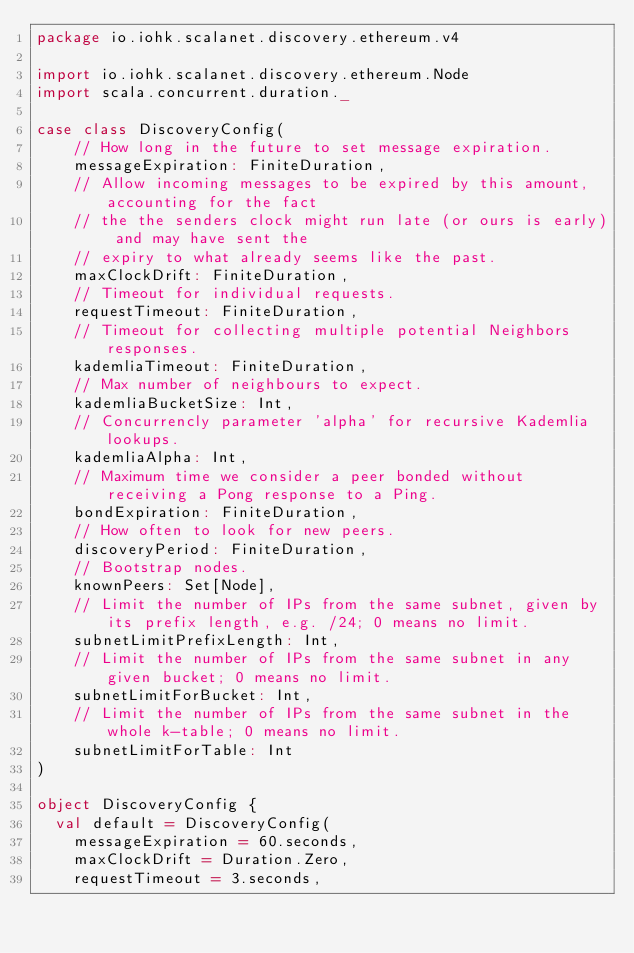Convert code to text. <code><loc_0><loc_0><loc_500><loc_500><_Scala_>package io.iohk.scalanet.discovery.ethereum.v4

import io.iohk.scalanet.discovery.ethereum.Node
import scala.concurrent.duration._

case class DiscoveryConfig(
    // How long in the future to set message expiration.
    messageExpiration: FiniteDuration,
    // Allow incoming messages to be expired by this amount, accounting for the fact
    // the the senders clock might run late (or ours is early) and may have sent the
    // expiry to what already seems like the past.
    maxClockDrift: FiniteDuration,
    // Timeout for individual requests.
    requestTimeout: FiniteDuration,
    // Timeout for collecting multiple potential Neighbors responses.
    kademliaTimeout: FiniteDuration,
    // Max number of neighbours to expect.
    kademliaBucketSize: Int,
    // Concurrencly parameter 'alpha' for recursive Kademlia lookups.
    kademliaAlpha: Int,
    // Maximum time we consider a peer bonded without receiving a Pong response to a Ping.
    bondExpiration: FiniteDuration,
    // How often to look for new peers.
    discoveryPeriod: FiniteDuration,
    // Bootstrap nodes.
    knownPeers: Set[Node],
    // Limit the number of IPs from the same subnet, given by its prefix length, e.g. /24; 0 means no limit.
    subnetLimitPrefixLength: Int,
    // Limit the number of IPs from the same subnet in any given bucket; 0 means no limit.
    subnetLimitForBucket: Int,
    // Limit the number of IPs from the same subnet in the whole k-table; 0 means no limit.
    subnetLimitForTable: Int
)

object DiscoveryConfig {
  val default = DiscoveryConfig(
    messageExpiration = 60.seconds,
    maxClockDrift = Duration.Zero,
    requestTimeout = 3.seconds,</code> 